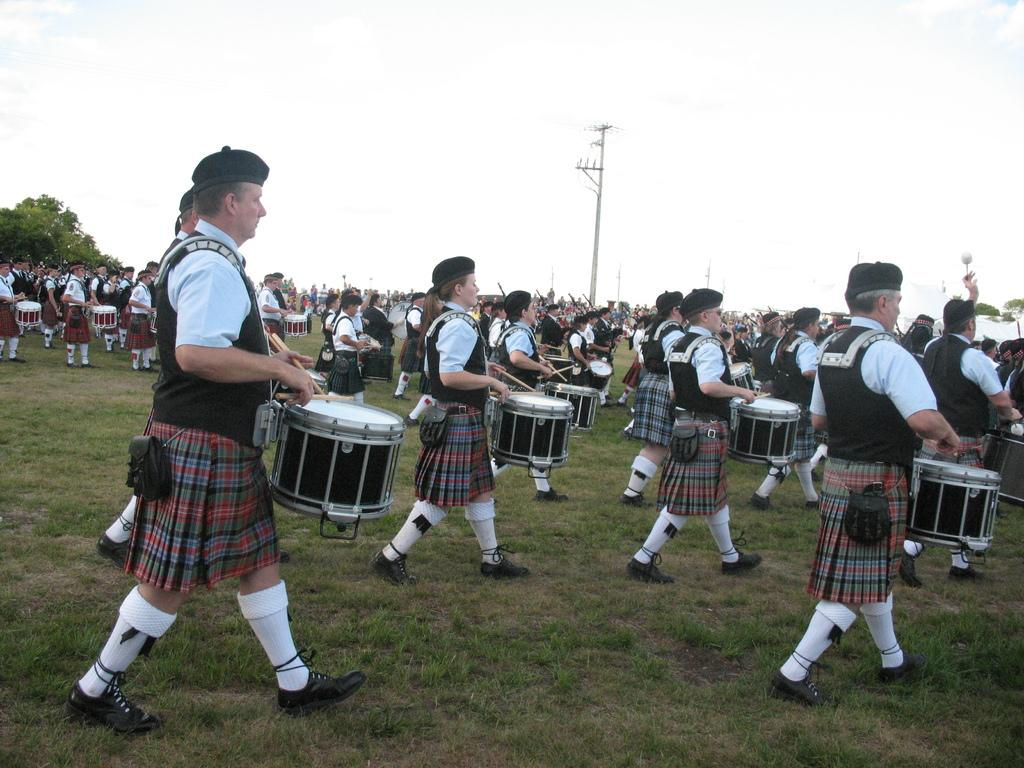What are the people in the image doing? The people in the image are walking and playing musical drums. What is the terrain like in the image? The land is covered with grass. What can be seen in the background of the image? The sky, a pole, and trees are present in the background. How many credits are required to purchase the property in the image? There is no property for sale in the image, and therefore no credits are required. What type of shelf can be seen in the image? There is no shelf present in the image. 